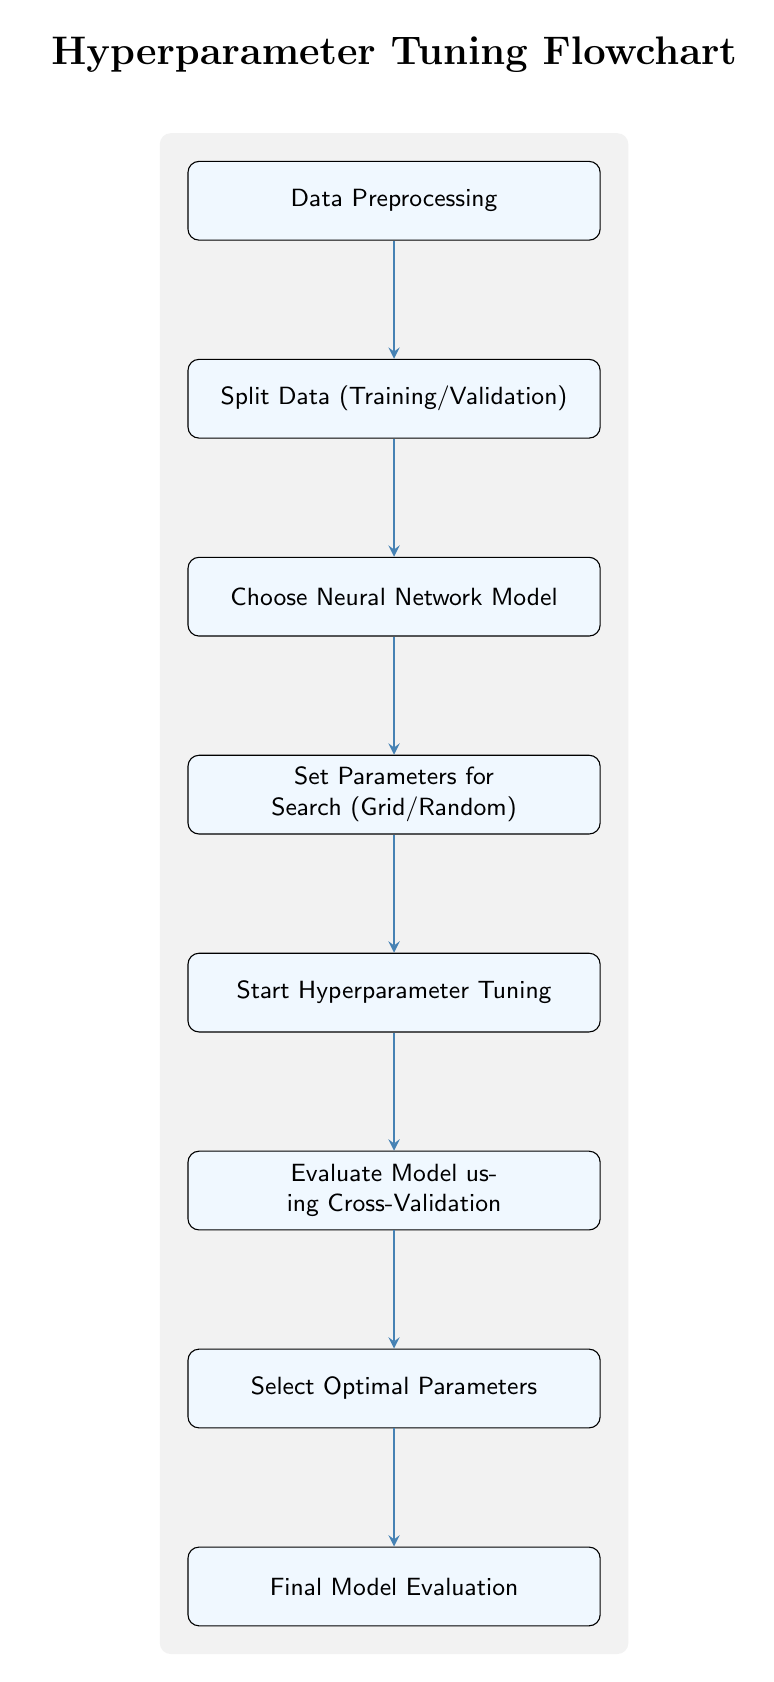What is the first step in the hyperparameter tuning process? The flowchart starts with "Data Preprocessing," which is the first node in the diagram.
Answer: Data Preprocessing How many total steps are there in the hyperparameter tuning flowchart? The diagram includes eight distinct steps: Data Preprocessing, Split Data (Training/Validation), Choose Neural Network Model, Set Parameters for Search (Grid/Random), Start Hyperparameter Tuning, Evaluate Model using Cross-Validation, Select Optimal Parameters, and Final Model Evaluation. Thus, there are eight steps in total.
Answer: Eight What is the last step in the hyperparameter tuning flowchart? The last step in the flowchart is "Final Model Evaluation," which appears at the bottom of the diagram.
Answer: Final Model Evaluation What parameter selection methods are mentioned in the diagram? The node "Set Parameters for Search" states that the parameter selection methods include Grid and Random search, showing two distinct techniques for hyperparameter tuning.
Answer: Grid/Random Which node directly follows the "Start Hyperparameter Tuning" step? According to the flow of the diagram, the node that follows "Start Hyperparameter Tuning" is "Evaluate Model using Cross-Validation." This indicates the sequential process after tuning begins.
Answer: Evaluate Model using Cross-Validation What is the relationship between "Choose Neural Network Model" and "Evaluate Model using Cross-Validation"? "Choose Neural Network Model" is positioned above "Evaluate Model using Cross-Validation" in the flowchart, indicating that selecting a model precedes evaluating its performance. The arrow drawn between these two nodes shows the directional flow of the process.
Answer: Sequential relationship What is the purpose of the cross-validation step in this flowchart? The "Evaluate Model using Cross-Validation" step acts as a mechanism to assess the model's performance and robustness with varying hyperparameters, ultimately aiding in the selection of the optimal parameters. This step is essential in validating the effectiveness of the chosen model and parameters.
Answer: Assess performance What shapes are used to represent the process steps in this flowchart? In the flowchart, process steps are represented as rectangles with rounded corners, which is a common shape used to denote actions or steps in a flowchart context.
Answer: Rectangles with rounded corners Which step involves selecting parameters before starting tuning? The step involved in selecting parameters prior to tuning is "Set Parameters for Search," indicating that parameters must be defined before the tuning process can begin.
Answer: Set Parameters for Search 